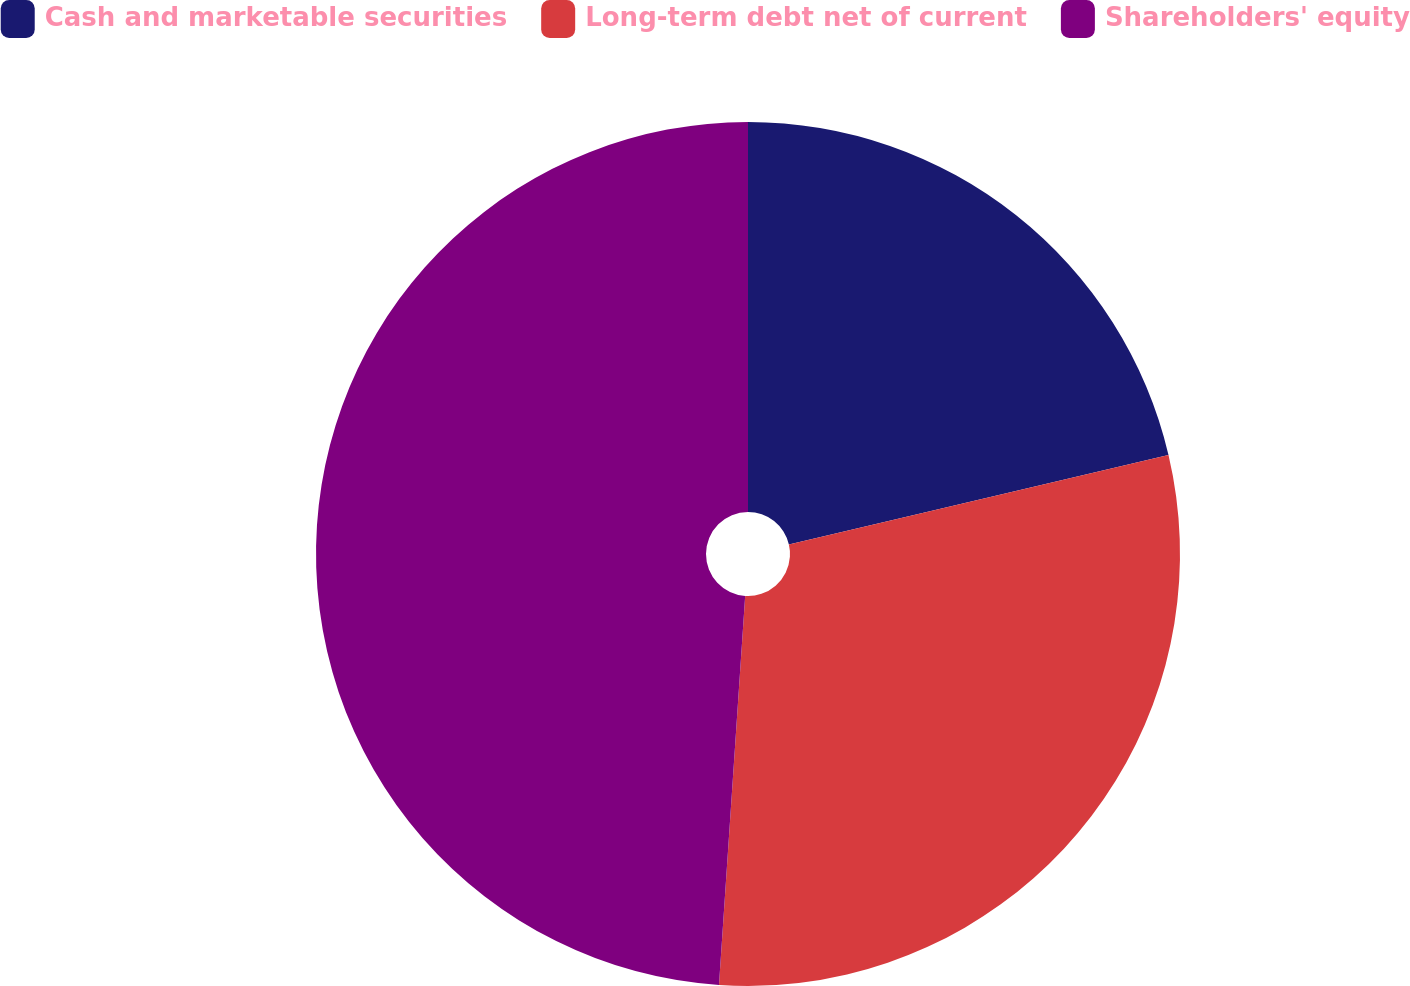Convert chart. <chart><loc_0><loc_0><loc_500><loc_500><pie_chart><fcel>Cash and marketable securities<fcel>Long-term debt net of current<fcel>Shareholders' equity<nl><fcel>21.32%<fcel>29.75%<fcel>48.93%<nl></chart> 